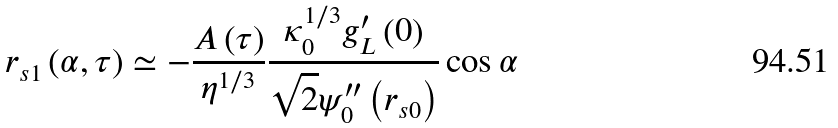<formula> <loc_0><loc_0><loc_500><loc_500>r _ { s 1 } \left ( \alpha , \tau \right ) \simeq - \frac { A \left ( \tau \right ) } { \eta ^ { 1 / 3 } } \frac { \kappa _ { 0 } ^ { 1 / 3 } g _ { L } ^ { \prime } \left ( 0 \right ) } { \sqrt { 2 } \psi _ { 0 } ^ { \prime \prime } \left ( r _ { s 0 } \right ) } \cos \alpha</formula> 